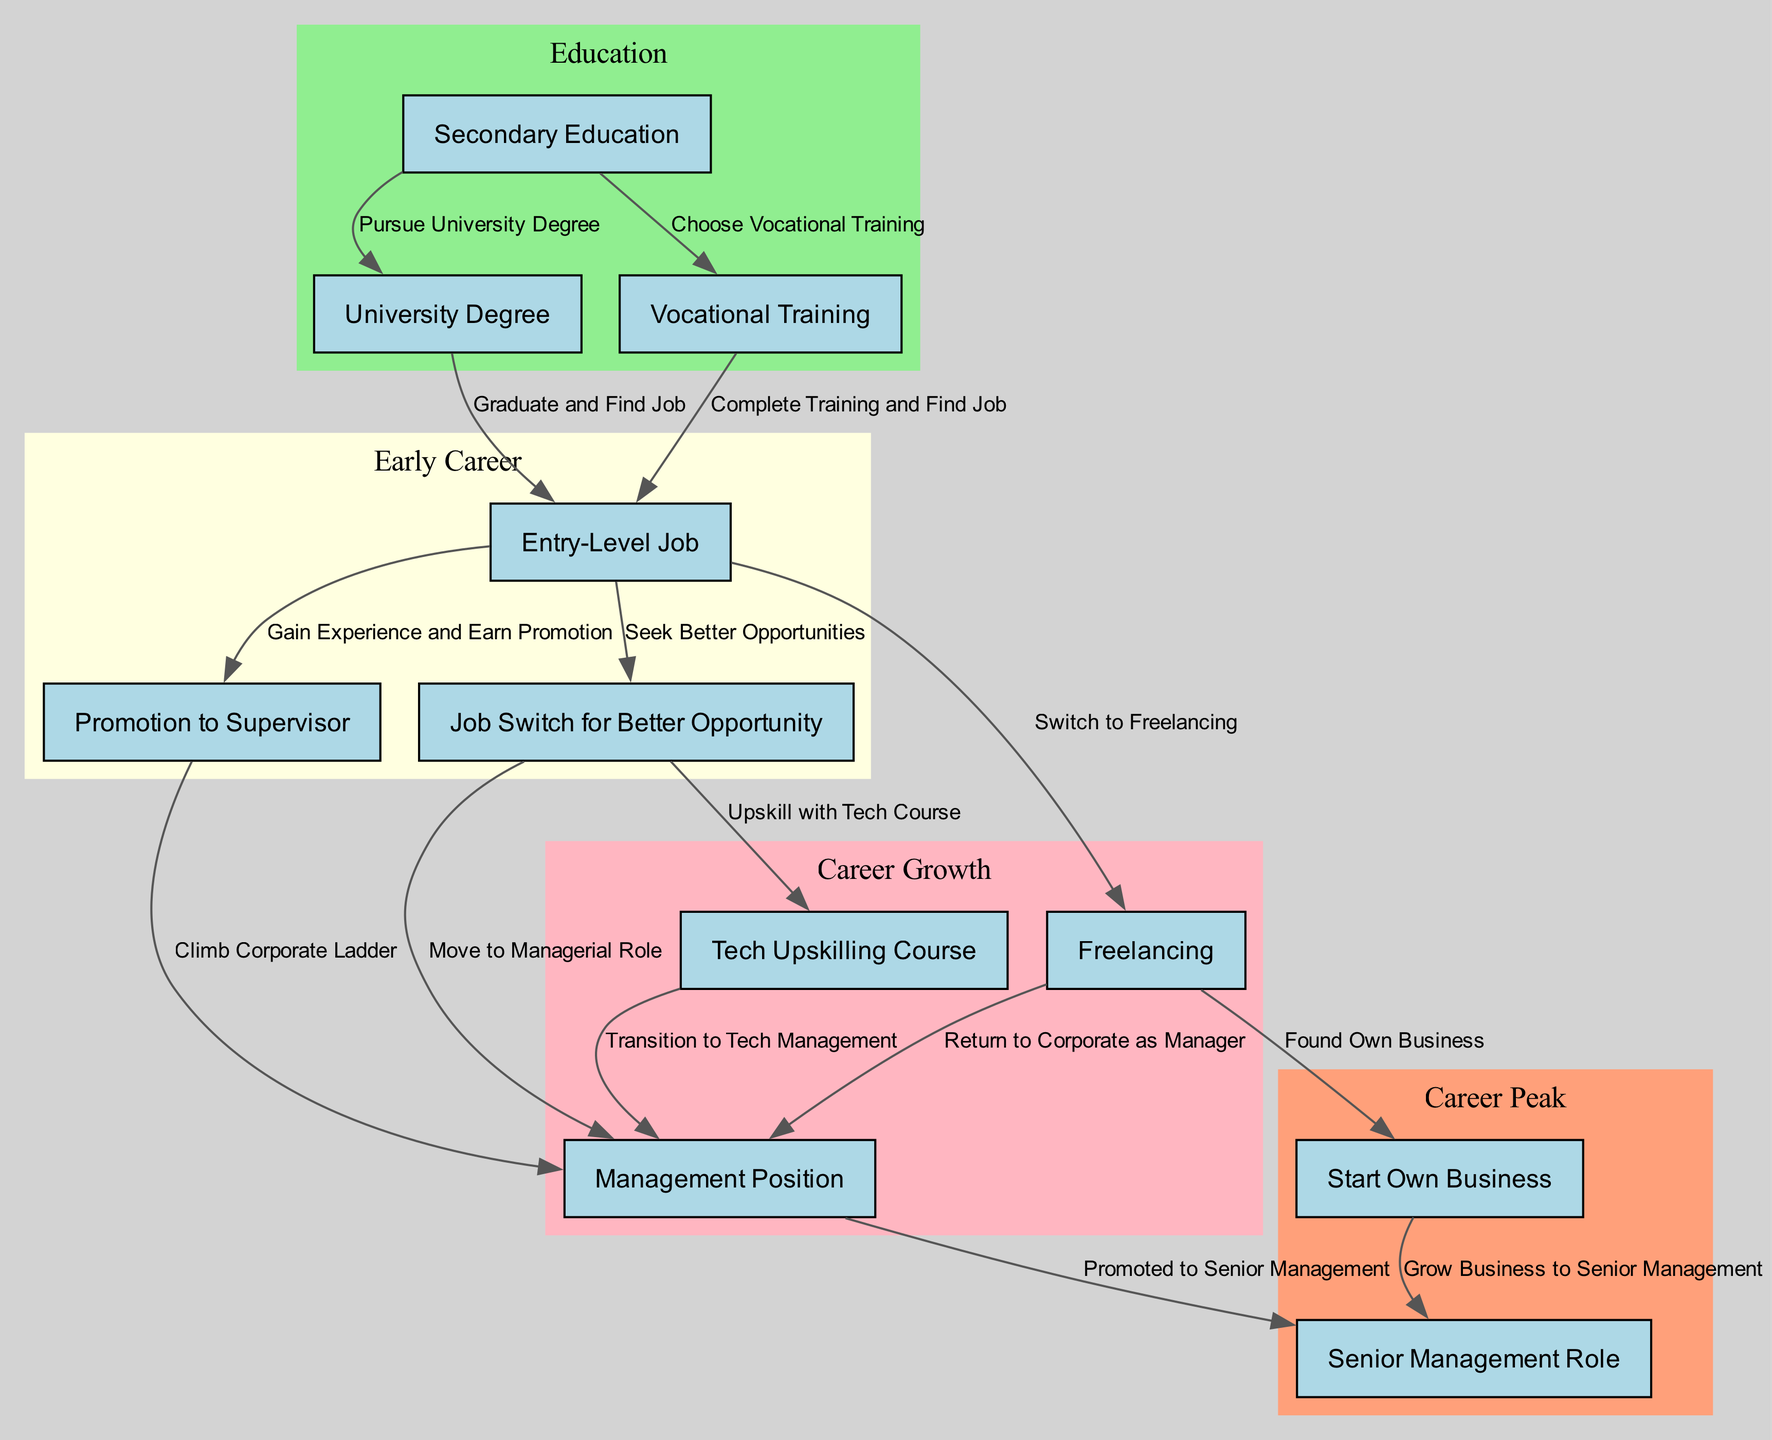What is the first milestone after secondary education? According to the diagram, after completing Secondary Education, the first milestone is to either pursue a University Degree or choose Vocational Training. The direct paths indicate that one would typically pursue a University Degree as the first option.
Answer: University Degree How many key milestones are identified for career progression? The diagram lists a total of 10 key milestones in the career progression of millennials, starting from Secondary Education to Senior Management. Each node represents a significant step along the career path.
Answer: 10 What is the connection between an entry-level job and a management position? The diagram shows that after starting with an Entry-Level Job, an individual can gain experience and earn a Promotion, leading to a Management Position. An alternative path is through a Job Switch that also leads to a Management Role.
Answer: Gain Experience and Earn Promotion Which training is an alternative route from an entry-level job towards a management role? The diagram presents the option of completing a Tech Upskilling Course as an alternative route from an Entry-Level Job to a Management Position. This shows how upskilling can facilitate career advancement.
Answer: Tech Upskilling Course What two options does freelancing lead to after initial engagement? From the diagram, engaging in Freelancing can lead to two potential outcomes: either starting one's own business or returning to a corporate role as a Manager. This outlines the flexibility of a freelancing option in a career.
Answer: Start Own Business and Return to Corporate as Manager How does vocational training relate to job opportunities? Vocational Training leads directly to securing an Entry-Level Job. This relationship indicates that individuals who choose vocational paths can quickly enter the workforce following their training.
Answer: Find Job What are the two outcomes after gaining a management position? After reaching a Management Position, the diagram indicates that one can either be promoted to a Senior Management Role or continue to climb the corporate ladder. This stresses the growth potential within management roles.
Answer: Promoted to Senior Management What is the main difference between the paths of freelancing and pursuing a university degree? The primary difference is that pursuing a University Degree typically leads directly into an Initial Job, whereas Freelancing may lead to various outcomes, including starting a business or returning to corporate roles. This shows distinct career trajectories based on initial choices.
Answer: Direct Job vs. Varied Outcomes How many edges connect vocational training to the job market? The diagram has two edges connecting the Vocational Training node to the job market, allowing individuals to reach Initial Jobs, thus demonstrating the relationship between vocational training and employment opportunities.
Answer: 2 